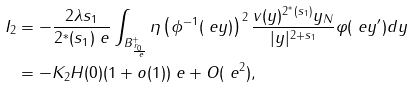<formula> <loc_0><loc_0><loc_500><loc_500>I _ { 2 } & = - \frac { 2 \lambda s _ { 1 } } { 2 ^ { * } ( s _ { 1 } ) \ e } \int _ { B _ { \frac { r _ { 0 } } { \ e } } ^ { + } } \eta \left ( \phi ^ { - 1 } ( \ e y ) \right ) ^ { 2 } \frac { v ( y ) ^ { 2 ^ { * } ( s _ { 1 } ) } y _ { N } } { | y | ^ { 2 + s _ { 1 } } } \varphi ( \ e y ^ { \prime } ) d y \\ & = - K _ { 2 } H ( 0 ) ( 1 + o ( 1 ) ) \ e + O ( \ e ^ { 2 } ) ,</formula> 